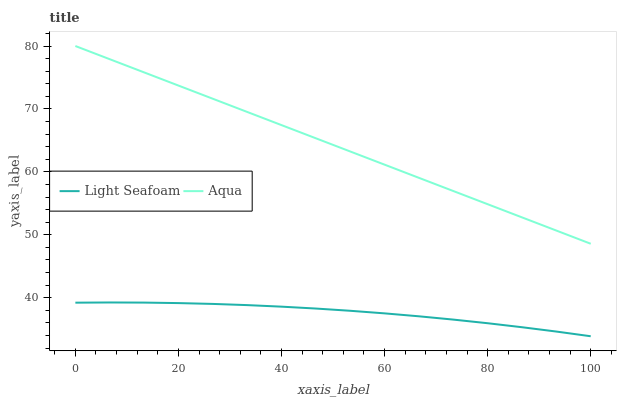Does Light Seafoam have the minimum area under the curve?
Answer yes or no. Yes. Does Aqua have the maximum area under the curve?
Answer yes or no. Yes. Does Aqua have the minimum area under the curve?
Answer yes or no. No. Is Aqua the smoothest?
Answer yes or no. Yes. Is Light Seafoam the roughest?
Answer yes or no. Yes. Is Aqua the roughest?
Answer yes or no. No. Does Light Seafoam have the lowest value?
Answer yes or no. Yes. Does Aqua have the lowest value?
Answer yes or no. No. Does Aqua have the highest value?
Answer yes or no. Yes. Is Light Seafoam less than Aqua?
Answer yes or no. Yes. Is Aqua greater than Light Seafoam?
Answer yes or no. Yes. Does Light Seafoam intersect Aqua?
Answer yes or no. No. 